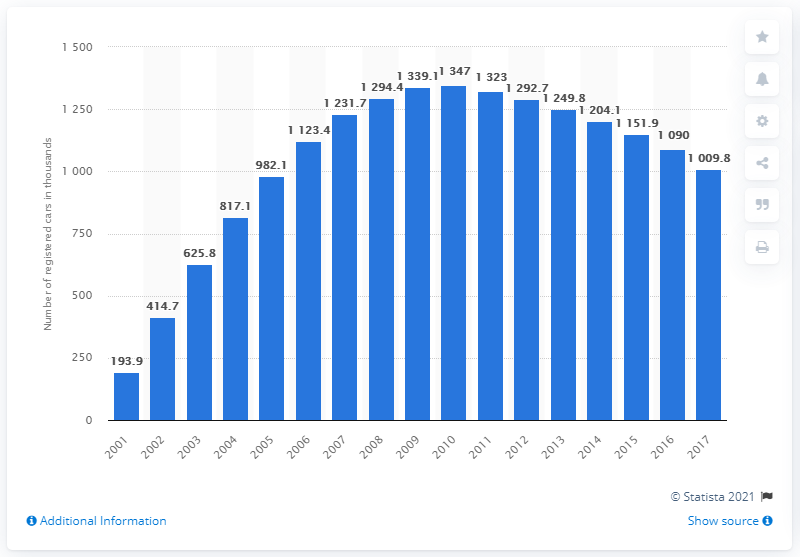Outline some significant characteristics in this image. The number of cars in band K began to decrease in 2011. 